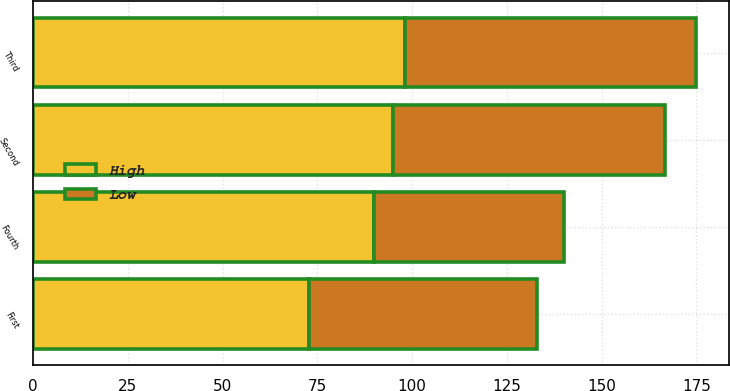<chart> <loc_0><loc_0><loc_500><loc_500><stacked_bar_chart><ecel><fcel>First<fcel>Second<fcel>Third<fcel>Fourth<nl><fcel>High<fcel>72.75<fcel>94.88<fcel>98.19<fcel>89.79<nl><fcel>Low<fcel>60.08<fcel>71.79<fcel>76.71<fcel>50.36<nl></chart> 